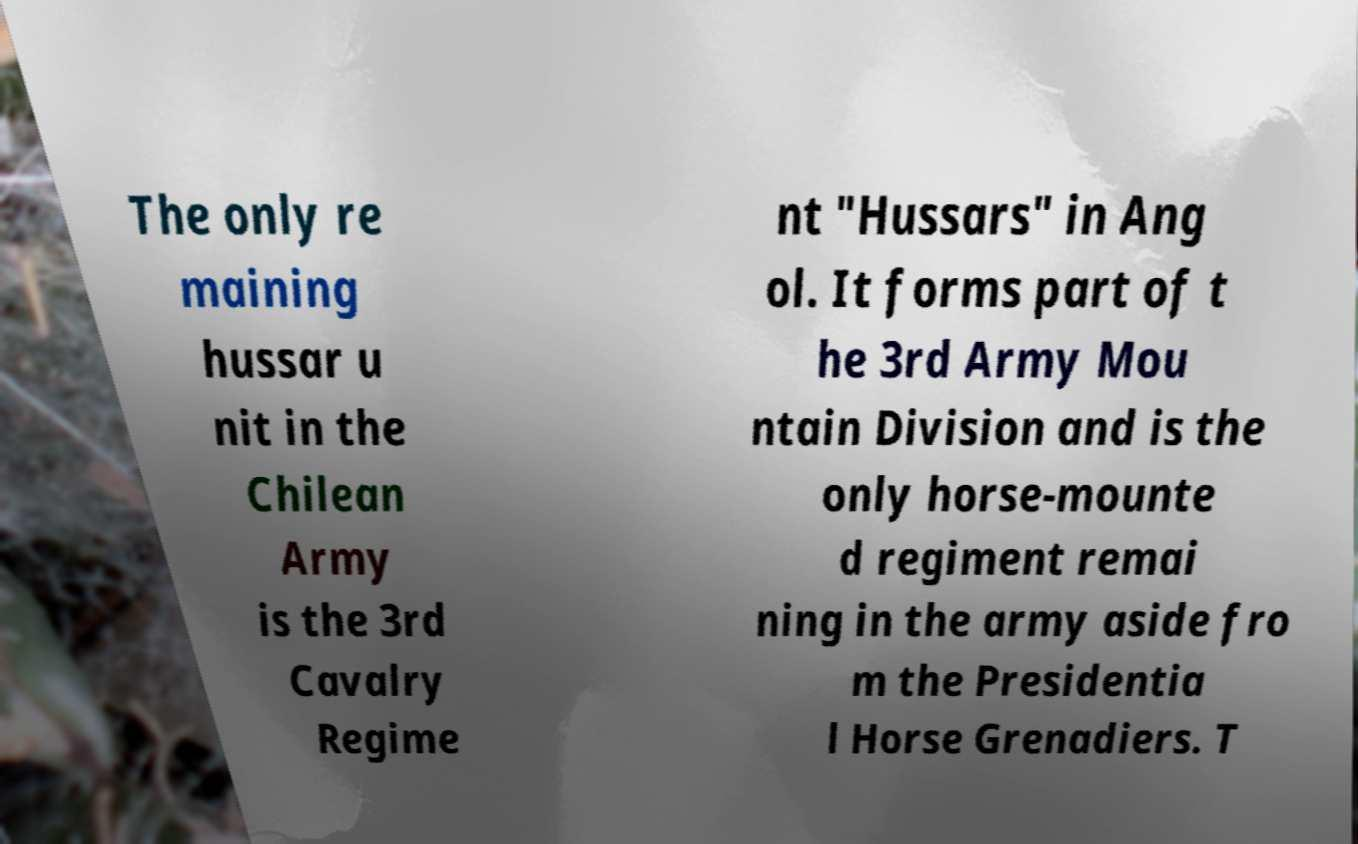Please identify and transcribe the text found in this image. The only re maining hussar u nit in the Chilean Army is the 3rd Cavalry Regime nt "Hussars" in Ang ol. It forms part of t he 3rd Army Mou ntain Division and is the only horse-mounte d regiment remai ning in the army aside fro m the Presidentia l Horse Grenadiers. T 